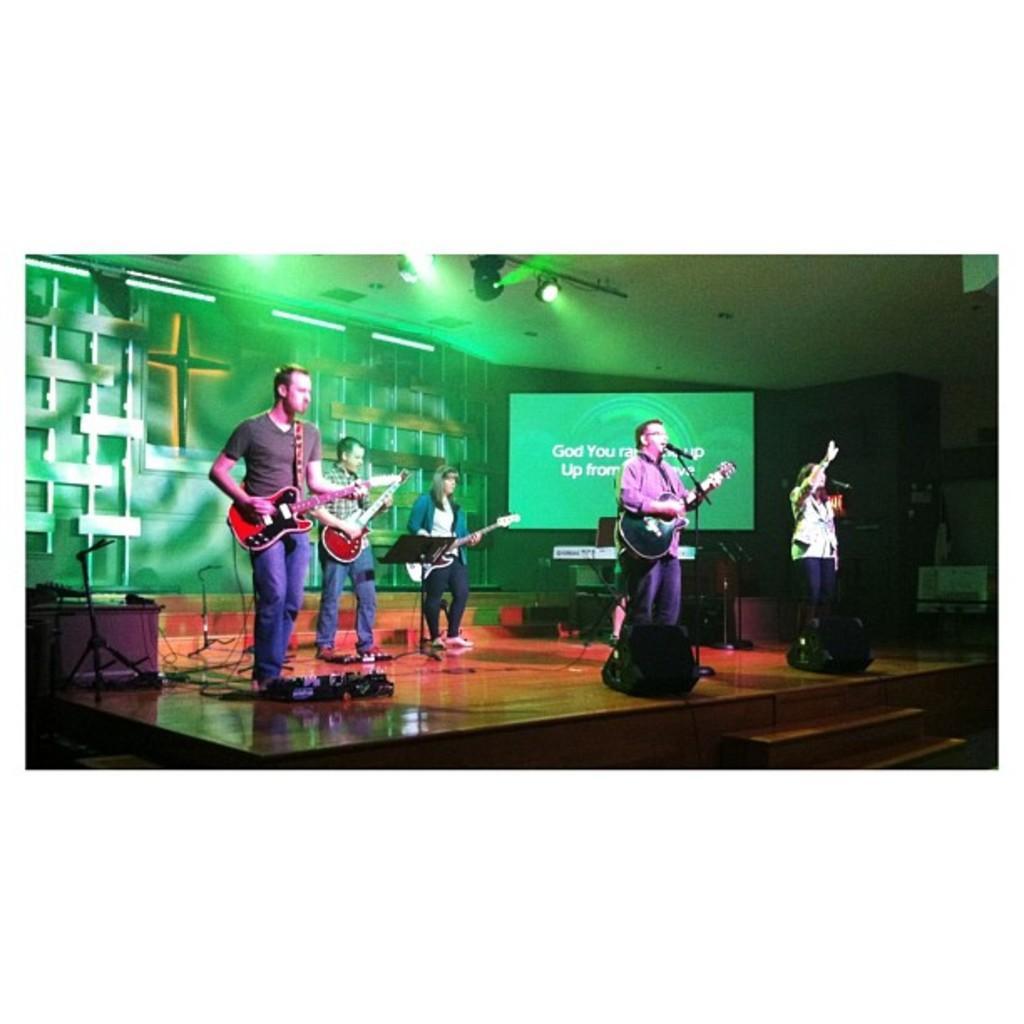Can you describe this image briefly? In this image i can see few persons standing on stage and playing some musical instruments at the back ground i can see a wall a screen, at the top there is a light. 